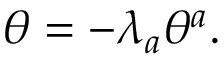<formula> <loc_0><loc_0><loc_500><loc_500>\theta = - \lambda _ { a } \theta ^ { a } .</formula> 